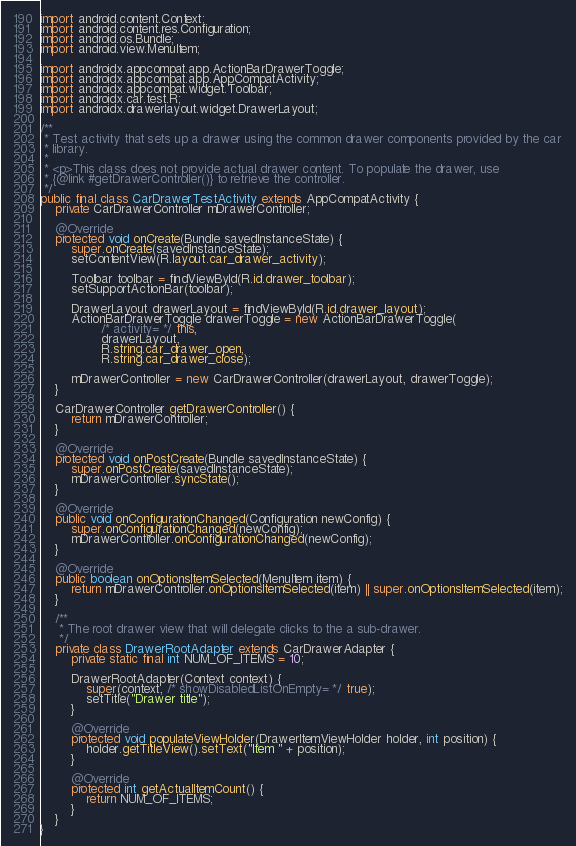<code> <loc_0><loc_0><loc_500><loc_500><_Java_>
import android.content.Context;
import android.content.res.Configuration;
import android.os.Bundle;
import android.view.MenuItem;

import androidx.appcompat.app.ActionBarDrawerToggle;
import androidx.appcompat.app.AppCompatActivity;
import androidx.appcompat.widget.Toolbar;
import androidx.car.test.R;
import androidx.drawerlayout.widget.DrawerLayout;

/**
 * Test activity that sets up a drawer using the common drawer components provided by the car
 * library.
 *
 * <p>This class does not provide actual drawer content. To populate the drawer, use
 * {@link #getDrawerController()} to retrieve the controller.
 */
public final class CarDrawerTestActivity extends AppCompatActivity {
    private CarDrawerController mDrawerController;

    @Override
    protected void onCreate(Bundle savedInstanceState) {
        super.onCreate(savedInstanceState);
        setContentView(R.layout.car_drawer_activity);

        Toolbar toolbar = findViewById(R.id.drawer_toolbar);
        setSupportActionBar(toolbar);

        DrawerLayout drawerLayout = findViewById(R.id.drawer_layout);
        ActionBarDrawerToggle drawerToggle = new ActionBarDrawerToggle(
                /* activity= */ this,
                drawerLayout,
                R.string.car_drawer_open,
                R.string.car_drawer_close);

        mDrawerController = new CarDrawerController(drawerLayout, drawerToggle);
    }

    CarDrawerController getDrawerController() {
        return mDrawerController;
    }

    @Override
    protected void onPostCreate(Bundle savedInstanceState) {
        super.onPostCreate(savedInstanceState);
        mDrawerController.syncState();
    }

    @Override
    public void onConfigurationChanged(Configuration newConfig) {
        super.onConfigurationChanged(newConfig);
        mDrawerController.onConfigurationChanged(newConfig);
    }

    @Override
    public boolean onOptionsItemSelected(MenuItem item) {
        return mDrawerController.onOptionsItemSelected(item) || super.onOptionsItemSelected(item);
    }

    /**
     * The root drawer view that will delegate clicks to the a sub-drawer.
     */
    private class DrawerRootAdapter extends CarDrawerAdapter {
        private static final int NUM_OF_ITEMS = 10;

        DrawerRootAdapter(Context context) {
            super(context, /* showDisabledListOnEmpty= */ true);
            setTitle("Drawer title");
        }

        @Override
        protected void populateViewHolder(DrawerItemViewHolder holder, int position) {
            holder.getTitleView().setText("Item " + position);
        }

        @Override
        protected int getActualItemCount() {
            return NUM_OF_ITEMS;
        }
    }
}
</code> 